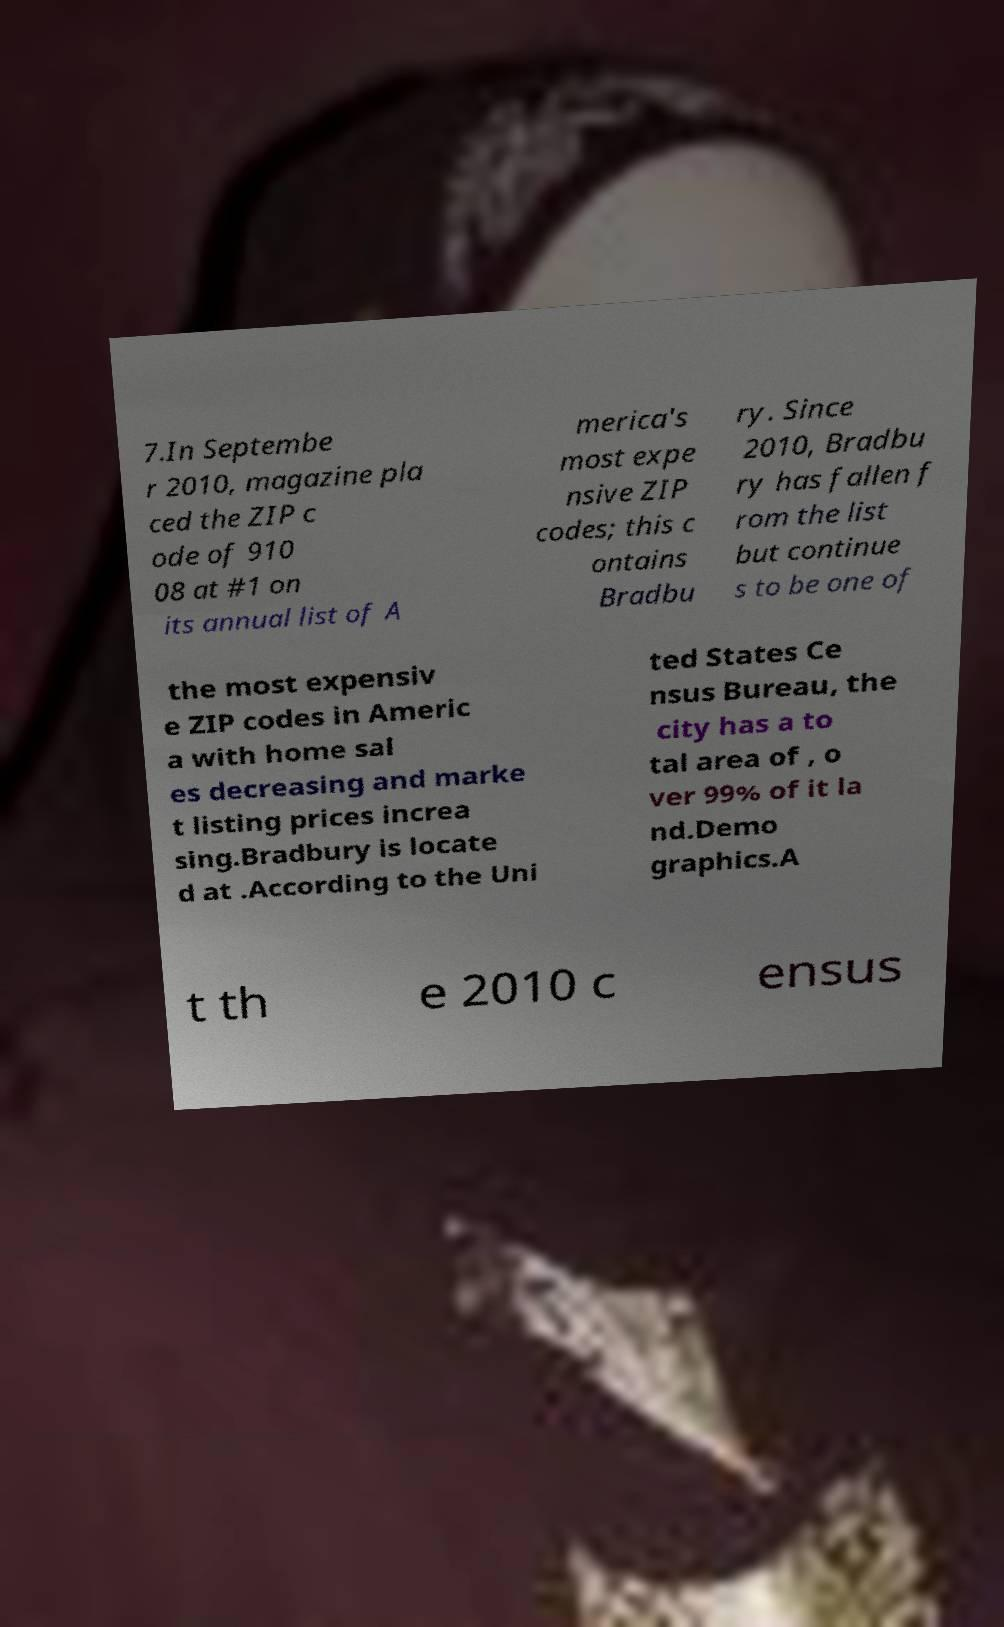There's text embedded in this image that I need extracted. Can you transcribe it verbatim? 7.In Septembe r 2010, magazine pla ced the ZIP c ode of 910 08 at #1 on its annual list of A merica's most expe nsive ZIP codes; this c ontains Bradbu ry. Since 2010, Bradbu ry has fallen f rom the list but continue s to be one of the most expensiv e ZIP codes in Americ a with home sal es decreasing and marke t listing prices increa sing.Bradbury is locate d at .According to the Uni ted States Ce nsus Bureau, the city has a to tal area of , o ver 99% of it la nd.Demo graphics.A t th e 2010 c ensus 